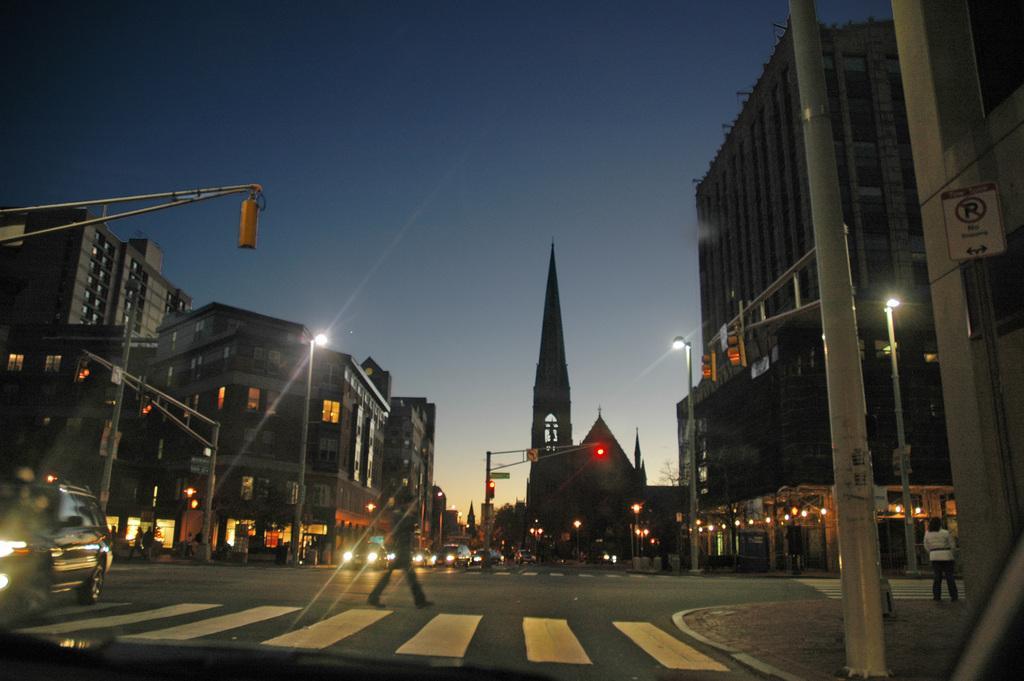Please provide a concise description of this image. In the background we can see sky. These are buildings. Here we can see traffic signals. We can see vehicles and people on the road. Here we can see a person walking. This is a zebra crossing. 